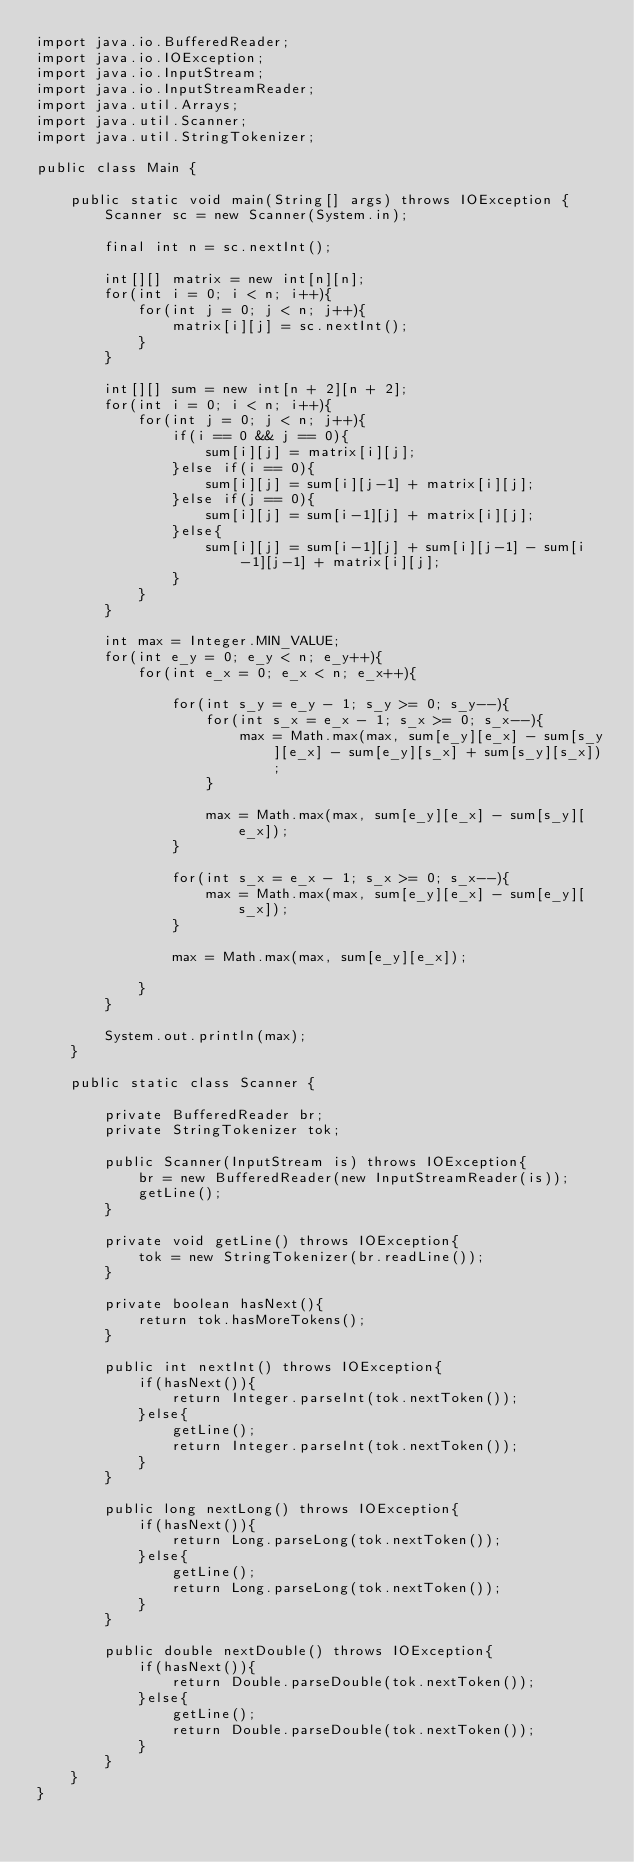Convert code to text. <code><loc_0><loc_0><loc_500><loc_500><_Java_>import java.io.BufferedReader;
import java.io.IOException;
import java.io.InputStream;
import java.io.InputStreamReader;
import java.util.Arrays;
import java.util.Scanner;
import java.util.StringTokenizer;

public class Main {
	
	public static void main(String[] args) throws IOException {
		Scanner sc = new Scanner(System.in);

		final int n = sc.nextInt();
		
		int[][] matrix = new int[n][n];
		for(int i = 0; i < n; i++){
			for(int j = 0; j < n; j++){
				matrix[i][j] = sc.nextInt();
			}
		}
		
		int[][] sum = new int[n + 2][n + 2];
		for(int i = 0; i < n; i++){
			for(int j = 0; j < n; j++){
				if(i == 0 && j == 0){
					sum[i][j] = matrix[i][j];
				}else if(i == 0){
					sum[i][j] = sum[i][j-1] + matrix[i][j];
				}else if(j == 0){
					sum[i][j] = sum[i-1][j] + matrix[i][j];
				}else{
					sum[i][j] = sum[i-1][j] + sum[i][j-1] - sum[i-1][j-1] + matrix[i][j];
				}
			}
		}
		
		int max = Integer.MIN_VALUE;
		for(int e_y = 0; e_y < n; e_y++){
			for(int e_x = 0; e_x < n; e_x++){
				
				for(int s_y = e_y - 1; s_y >= 0; s_y--){
					for(int s_x = e_x - 1; s_x >= 0; s_x--){
						max = Math.max(max, sum[e_y][e_x] - sum[s_y][e_x] - sum[e_y][s_x] + sum[s_y][s_x]);
					}
					
					max = Math.max(max, sum[e_y][e_x] - sum[s_y][e_x]);
				}
				
				for(int s_x = e_x - 1; s_x >= 0; s_x--){
					max = Math.max(max, sum[e_y][e_x] - sum[e_y][s_x]);
				}
				
				max = Math.max(max, sum[e_y][e_x]);
				
			}
		}
		
		System.out.println(max);
	}
	
	public static class Scanner {
		
		private BufferedReader br;
		private StringTokenizer tok;
		
		public Scanner(InputStream is) throws IOException{
			br = new BufferedReader(new InputStreamReader(is));
			getLine();
		}
		
		private void getLine() throws IOException{
			tok = new StringTokenizer(br.readLine());
		}
		
		private boolean hasNext(){
			return tok.hasMoreTokens();
		}
		
		public int nextInt() throws IOException{
			if(hasNext()){
				return Integer.parseInt(tok.nextToken());
			}else{
				getLine();
				return Integer.parseInt(tok.nextToken());
			}
		}
		
		public long nextLong() throws IOException{
			if(hasNext()){
				return Long.parseLong(tok.nextToken());
			}else{
				getLine();
				return Long.parseLong(tok.nextToken());
			}
		}
		
		public double nextDouble() throws IOException{
			if(hasNext()){
				return Double.parseDouble(tok.nextToken());
			}else{
				getLine();
				return Double.parseDouble(tok.nextToken());
			}
		}
	}
}</code> 